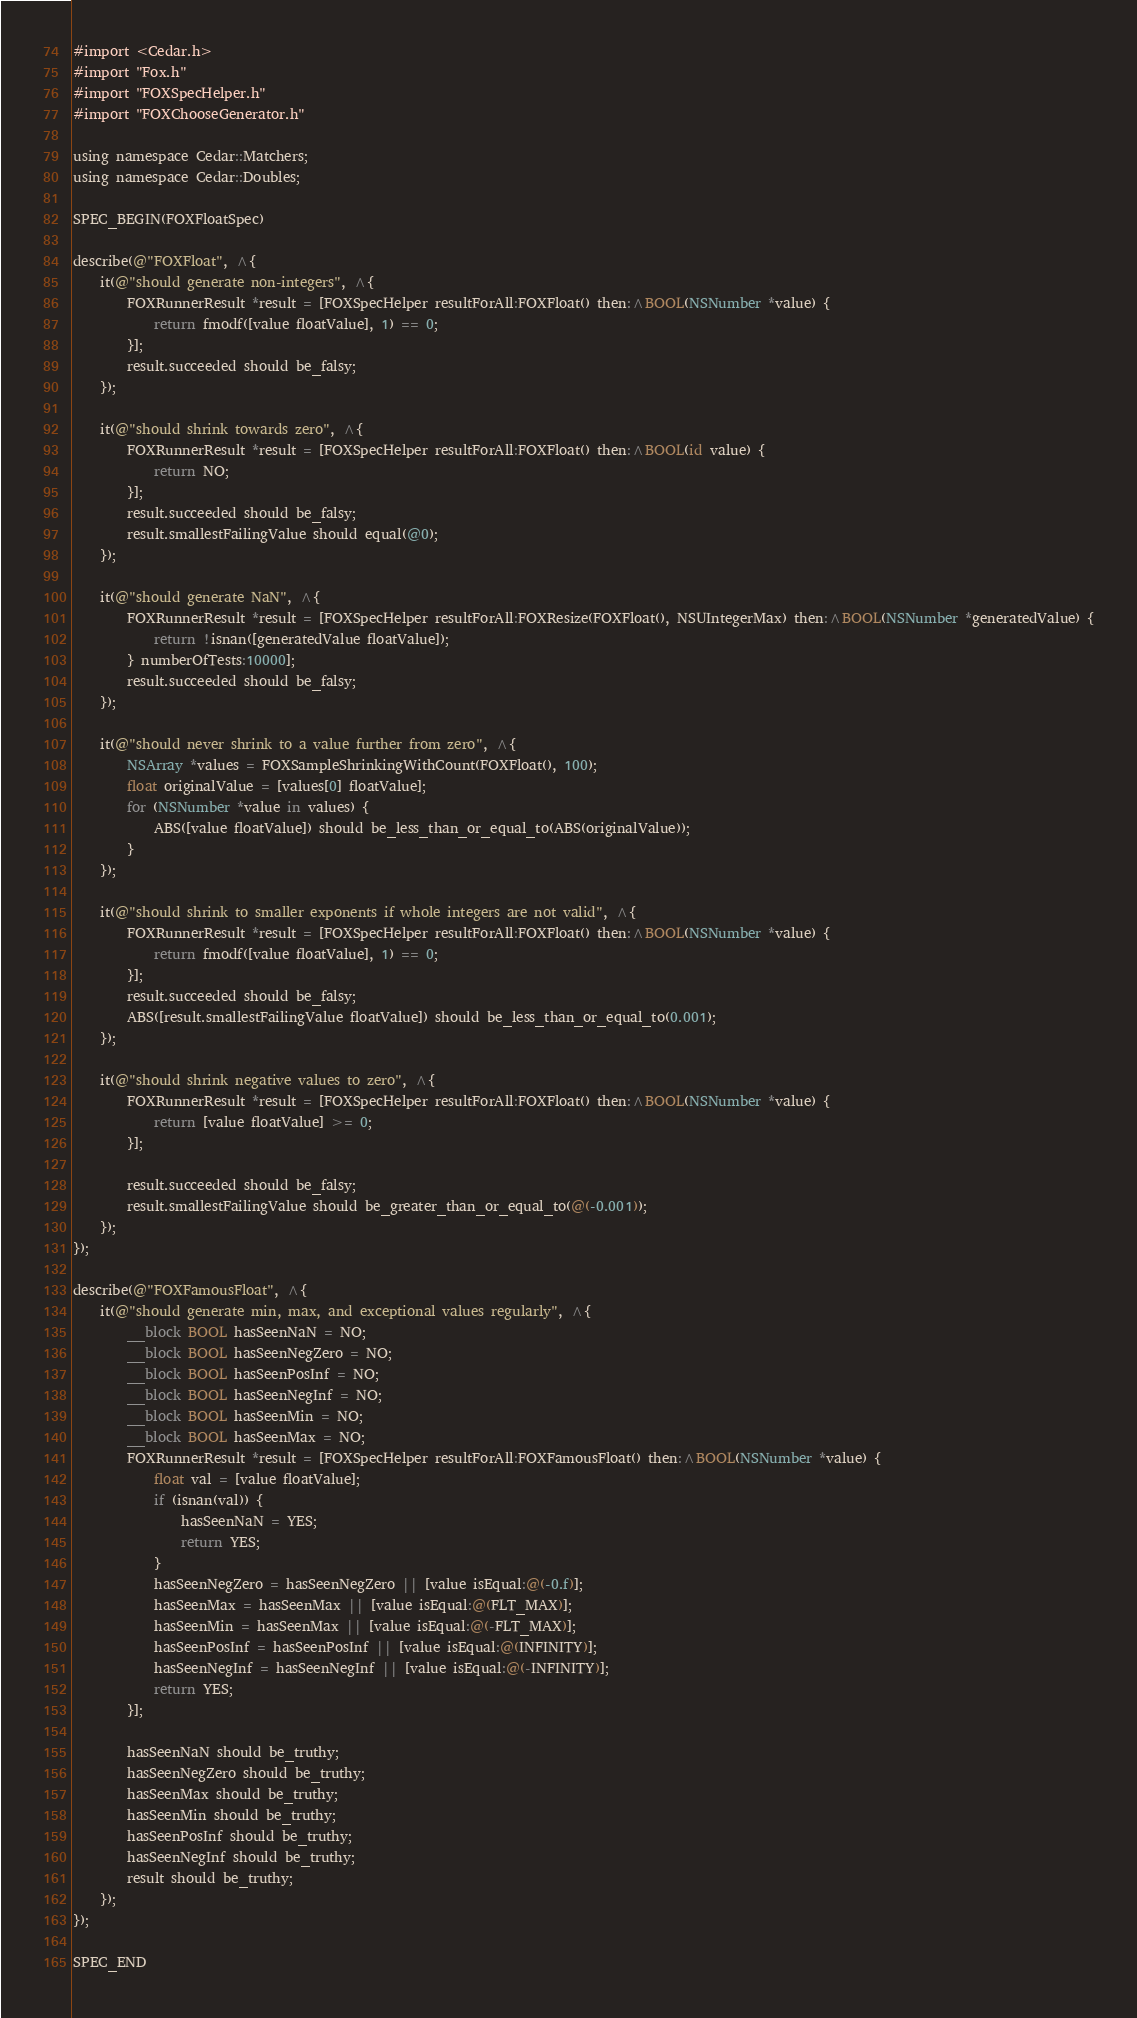Convert code to text. <code><loc_0><loc_0><loc_500><loc_500><_ObjectiveC_>#import <Cedar.h>
#import "Fox.h"
#import "FOXSpecHelper.h"
#import "FOXChooseGenerator.h"

using namespace Cedar::Matchers;
using namespace Cedar::Doubles;

SPEC_BEGIN(FOXFloatSpec)

describe(@"FOXFloat", ^{
    it(@"should generate non-integers", ^{
        FOXRunnerResult *result = [FOXSpecHelper resultForAll:FOXFloat() then:^BOOL(NSNumber *value) {
            return fmodf([value floatValue], 1) == 0;
        }];
        result.succeeded should be_falsy;
    });

    it(@"should shrink towards zero", ^{
        FOXRunnerResult *result = [FOXSpecHelper resultForAll:FOXFloat() then:^BOOL(id value) {
            return NO;
        }];
        result.succeeded should be_falsy;
        result.smallestFailingValue should equal(@0);
    });

    it(@"should generate NaN", ^{
        FOXRunnerResult *result = [FOXSpecHelper resultForAll:FOXResize(FOXFloat(), NSUIntegerMax) then:^BOOL(NSNumber *generatedValue) {
            return !isnan([generatedValue floatValue]);
        } numberOfTests:10000];
        result.succeeded should be_falsy;
    });

    it(@"should never shrink to a value further from zero", ^{
        NSArray *values = FOXSampleShrinkingWithCount(FOXFloat(), 100);
        float originalValue = [values[0] floatValue];
        for (NSNumber *value in values) {
            ABS([value floatValue]) should be_less_than_or_equal_to(ABS(originalValue));
        }
    });

    it(@"should shrink to smaller exponents if whole integers are not valid", ^{
        FOXRunnerResult *result = [FOXSpecHelper resultForAll:FOXFloat() then:^BOOL(NSNumber *value) {
            return fmodf([value floatValue], 1) == 0;
        }];
        result.succeeded should be_falsy;
        ABS([result.smallestFailingValue floatValue]) should be_less_than_or_equal_to(0.001);
    });

    it(@"should shrink negative values to zero", ^{
        FOXRunnerResult *result = [FOXSpecHelper resultForAll:FOXFloat() then:^BOOL(NSNumber *value) {
            return [value floatValue] >= 0;
        }];

        result.succeeded should be_falsy;
        result.smallestFailingValue should be_greater_than_or_equal_to(@(-0.001));
    });
});

describe(@"FOXFamousFloat", ^{
    it(@"should generate min, max, and exceptional values regularly", ^{
        __block BOOL hasSeenNaN = NO;
        __block BOOL hasSeenNegZero = NO;
        __block BOOL hasSeenPosInf = NO;
        __block BOOL hasSeenNegInf = NO;
        __block BOOL hasSeenMin = NO;
        __block BOOL hasSeenMax = NO;
        FOXRunnerResult *result = [FOXSpecHelper resultForAll:FOXFamousFloat() then:^BOOL(NSNumber *value) {
            float val = [value floatValue];
            if (isnan(val)) {
                hasSeenNaN = YES;
                return YES;
            }
            hasSeenNegZero = hasSeenNegZero || [value isEqual:@(-0.f)];
            hasSeenMax = hasSeenMax || [value isEqual:@(FLT_MAX)];
            hasSeenMin = hasSeenMax || [value isEqual:@(-FLT_MAX)];
            hasSeenPosInf = hasSeenPosInf || [value isEqual:@(INFINITY)];
            hasSeenNegInf = hasSeenNegInf || [value isEqual:@(-INFINITY)];
            return YES;
        }];

        hasSeenNaN should be_truthy;
        hasSeenNegZero should be_truthy;
        hasSeenMax should be_truthy;
        hasSeenMin should be_truthy;
        hasSeenPosInf should be_truthy;
        hasSeenNegInf should be_truthy;
        result should be_truthy;
    });
});

SPEC_END
</code> 